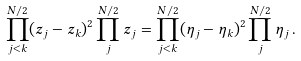<formula> <loc_0><loc_0><loc_500><loc_500>\prod _ { j < k } ^ { N / 2 } ( z _ { j } - z _ { k } ) ^ { 2 } \prod _ { j } ^ { N / 2 } z _ { j } = \prod _ { j < k } ^ { N / 2 } ( \eta _ { j } - \eta _ { k } ) ^ { 2 } \prod _ { j } ^ { N / 2 } \eta _ { j } \, .</formula> 